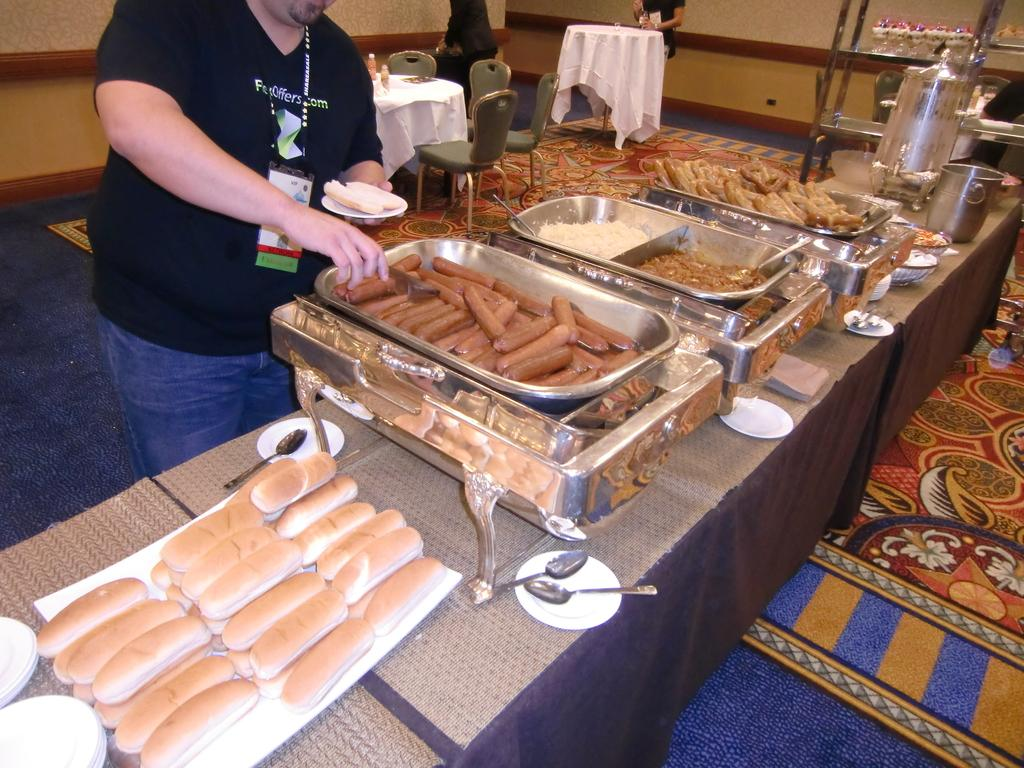What is on the table in the image? There are items placed on the table in the image. What is the person holding in the image? One person is holding a plate in the image. What type of furniture is visible in the image? Chairs are visible in the image. What can be seen in the background of the image? Tables are arranged in the background. What arithmetic problem is being solved on the table in the image? There is no arithmetic problem visible on the table in the image. Are there any horses present in the image? There are no horses present in the image. 